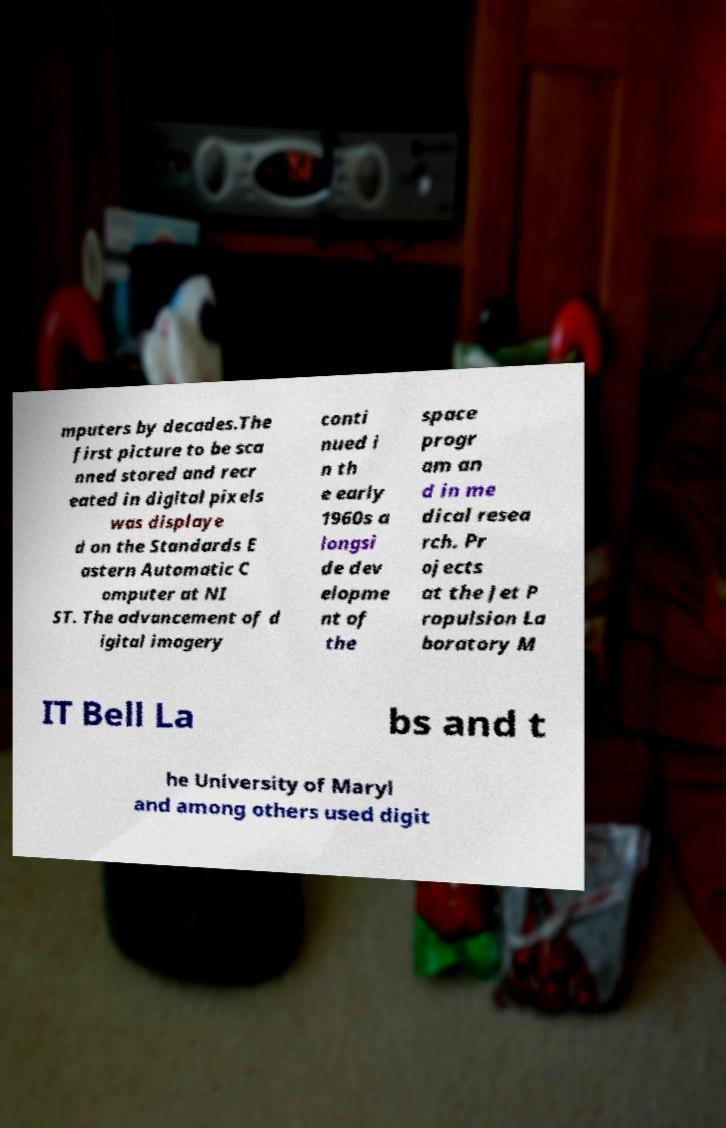Can you accurately transcribe the text from the provided image for me? mputers by decades.The first picture to be sca nned stored and recr eated in digital pixels was displaye d on the Standards E astern Automatic C omputer at NI ST. The advancement of d igital imagery conti nued i n th e early 1960s a longsi de dev elopme nt of the space progr am an d in me dical resea rch. Pr ojects at the Jet P ropulsion La boratory M IT Bell La bs and t he University of Maryl and among others used digit 